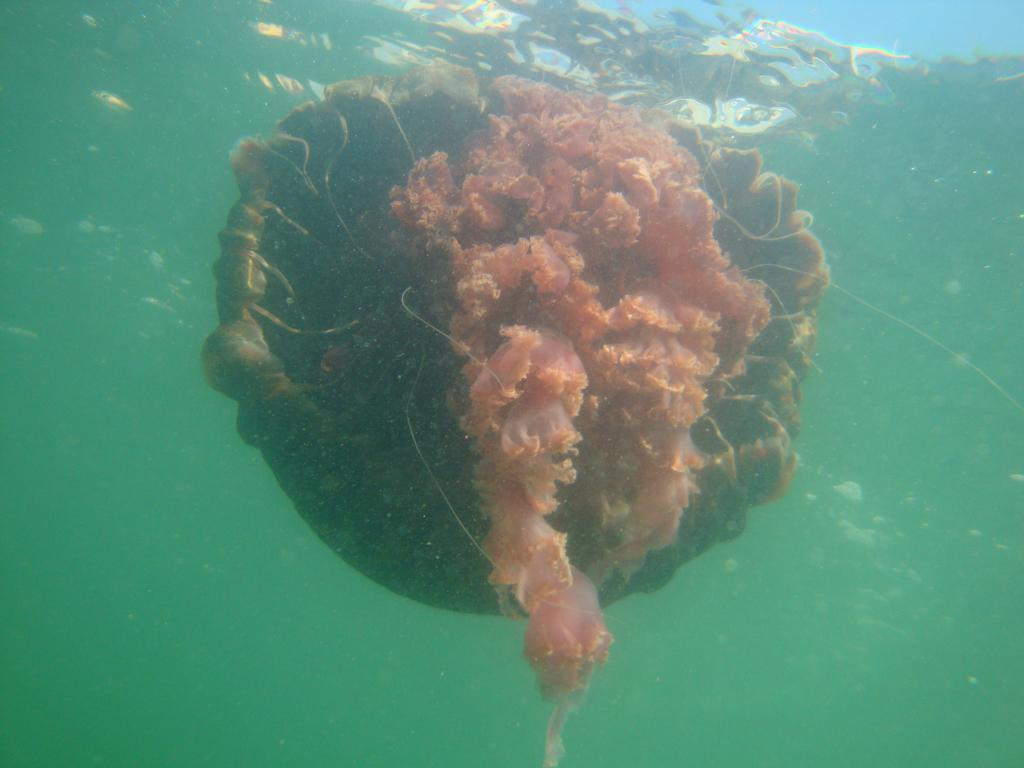What type of animals are in the image? There are jellyfish in the image. Where are the jellyfish located? The jellyfish are in the water. What type of can is visible in the image? There is no can present in the image; it features jellyfish in the water. How many legs can be seen on the jellyfish in the image? Jellyfish do not have legs, so none can be seen on them in the image. 